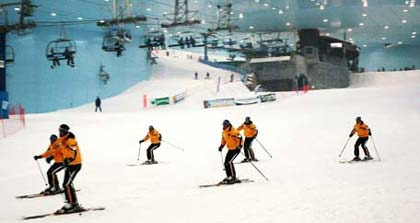Is there any branding or advertising visible in the image? Yes, there are banners along the sides of the slope which likely represent branding or advertisements. These banners could promote various sponsors, events, or services related to the indoor skiing facility. Can you create a fictional scenario involving the skiers in the image? Certainly! Imagine that the skiers in the image are part of an elite skiing team participating in an international training camp. They have come to this cutting-edge indoor facility to practice their skills regardless of the season. Their uniforms highlight their team spirit and commitment. Throughout the camp, they participate in rigorous training sessions, technique workshops, and team-building activities, all aiming to prepare them for the upcoming Winter Olympics. The ski lift takes them back to the top after each thrilling run, and they share tips and encouragement, knowing that their teamwork and practice today will lead to success tomorrow. 